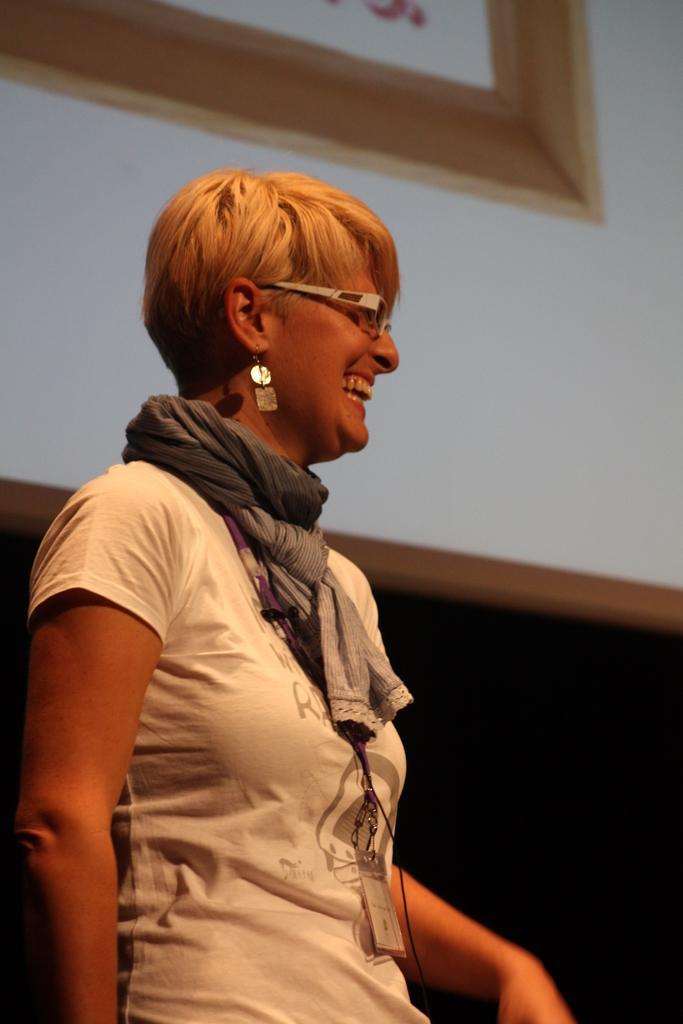In one or two sentences, can you explain what this image depicts? In this image we can see a lady wearing specs, scarf, earring and a tag. In the back there is a wall with a photo frame. 